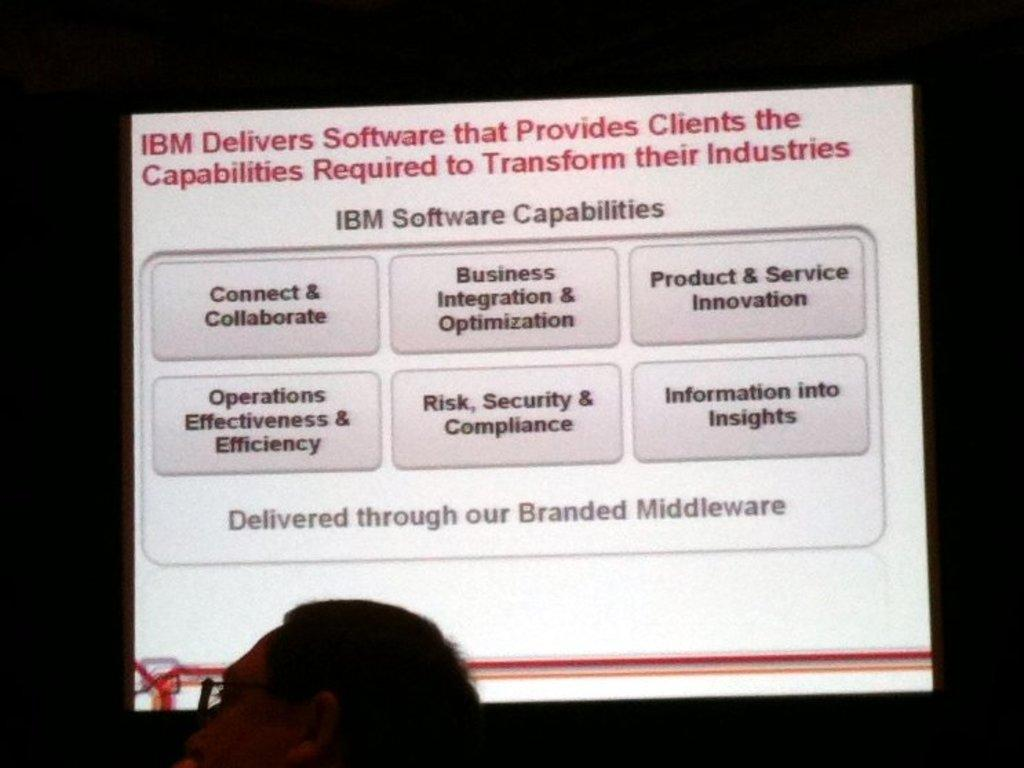What is the main object in the image? There is a screen in the image. What can be seen on the screen? There are texts visible on the screen. What type of arm is visible on the screen? There is no arm visible on the screen; the image only shows a screen with texts. 